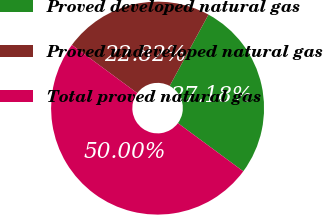Convert chart to OTSL. <chart><loc_0><loc_0><loc_500><loc_500><pie_chart><fcel>Proved developed natural gas<fcel>Proved undeveloped natural gas<fcel>Total proved natural gas<nl><fcel>27.18%<fcel>22.82%<fcel>50.0%<nl></chart> 